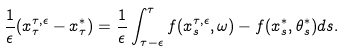Convert formula to latex. <formula><loc_0><loc_0><loc_500><loc_500>\frac { 1 } { \epsilon } ( x ^ { \tau , \epsilon } _ { \tau } - x ^ { * } _ { \tau } ) & = \frac { 1 } { \epsilon } \int _ { \tau - \epsilon } ^ { \tau } f ( x ^ { \tau , \epsilon } _ { s } , \omega ) - f ( x ^ { * } _ { s } , \theta ^ { * } _ { s } ) d s .</formula> 